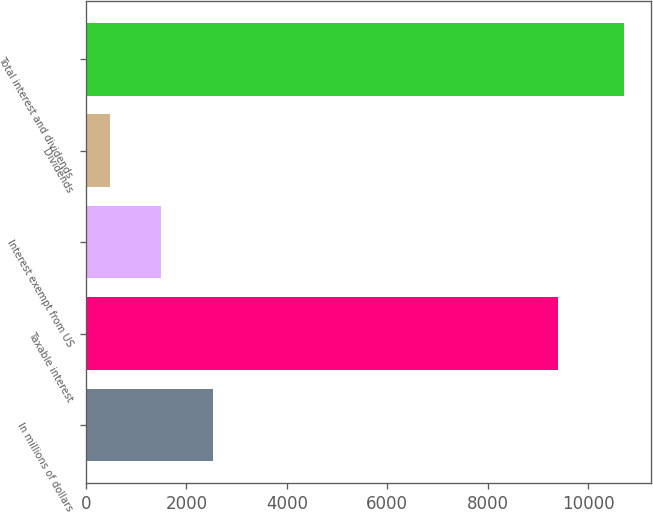Convert chart. <chart><loc_0><loc_0><loc_500><loc_500><bar_chart><fcel>In millions of dollars<fcel>Taxable interest<fcel>Interest exempt from US<fcel>Dividends<fcel>Total interest and dividends<nl><fcel>2523.6<fcel>9407<fcel>1499.3<fcel>475<fcel>10718<nl></chart> 